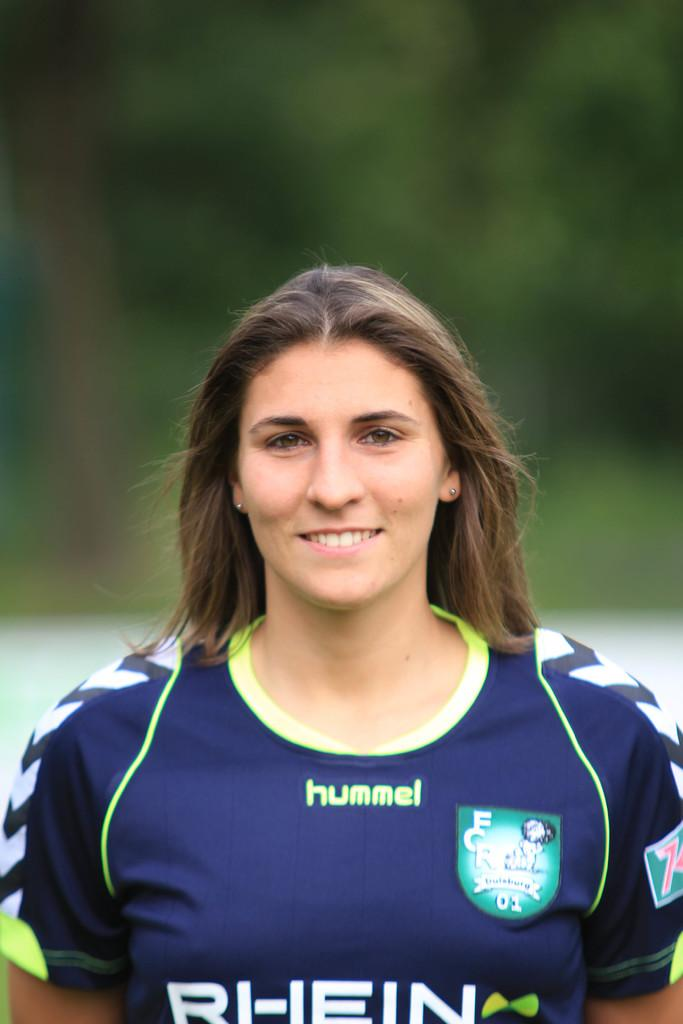<image>
Render a clear and concise summary of the photo. Woman posing for a photo while wearing a jersey which says "HUMMEL". 